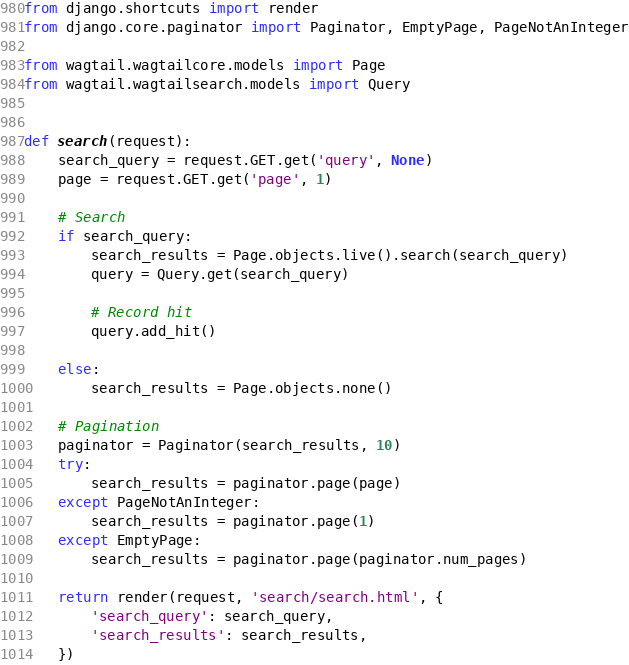<code> <loc_0><loc_0><loc_500><loc_500><_Python_>from django.shortcuts import render
from django.core.paginator import Paginator, EmptyPage, PageNotAnInteger

from wagtail.wagtailcore.models import Page
from wagtail.wagtailsearch.models import Query


def search(request):
    search_query = request.GET.get('query', None)
    page = request.GET.get('page', 1)

    # Search
    if search_query:
        search_results = Page.objects.live().search(search_query)
        query = Query.get(search_query)

        # Record hit
        query.add_hit()

    else:
        search_results = Page.objects.none()

    # Pagination
    paginator = Paginator(search_results, 10)
    try:
        search_results = paginator.page(page)
    except PageNotAnInteger:
        search_results = paginator.page(1)
    except EmptyPage:
        search_results = paginator.page(paginator.num_pages)

    return render(request, 'search/search.html', {
        'search_query': search_query,
        'search_results': search_results,
    })
</code> 